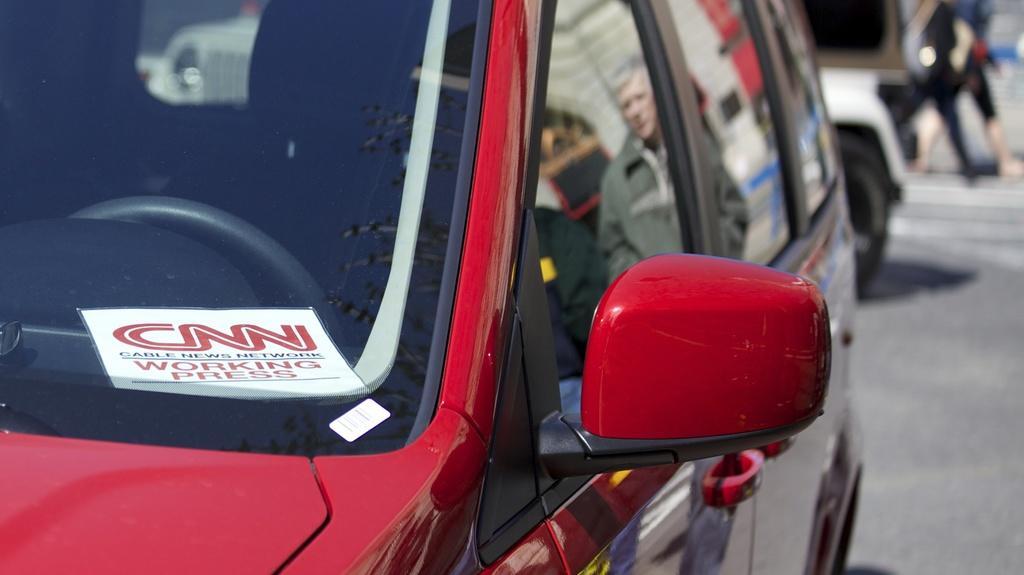Describe this image in one or two sentences. In this image we can see motor vehicles on the road. 